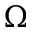Convert formula to latex. <formula><loc_0><loc_0><loc_500><loc_500>\Omega</formula> 